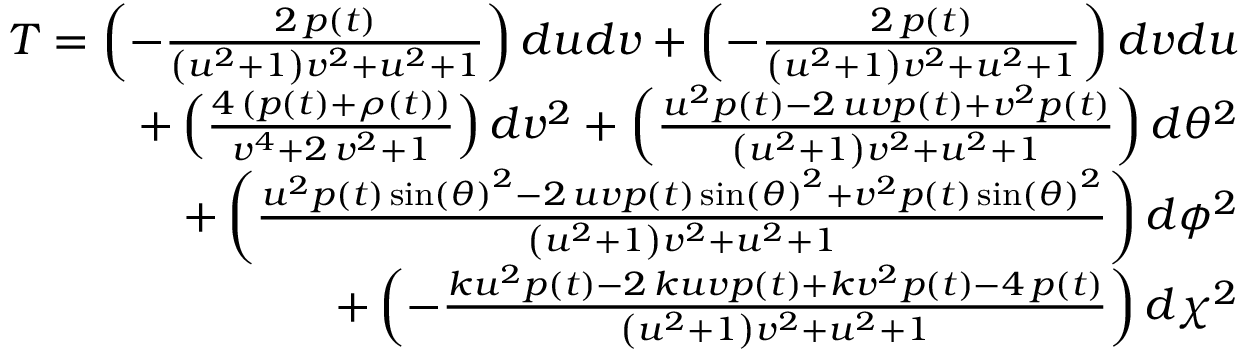Convert formula to latex. <formula><loc_0><loc_0><loc_500><loc_500>\begin{array} { r } { T = \left ( - \frac { 2 \, p \left ( t \right ) } { { \left ( u ^ { 2 } + 1 \right ) } v ^ { 2 } + u ^ { 2 } + 1 } \right ) d u d v + \left ( - \frac { 2 \, p \left ( t \right ) } { { \left ( u ^ { 2 } + 1 \right ) } v ^ { 2 } + u ^ { 2 } + 1 } \right ) d v d u } \\ { + \left ( \frac { 4 \, { \left ( p \left ( t \right ) + \rho \left ( t \right ) \right ) } } { v ^ { 4 } + 2 \, v ^ { 2 } + 1 } \right ) d v ^ { 2 } + \left ( \frac { u ^ { 2 } p \left ( t \right ) - 2 \, u v p \left ( t \right ) + v ^ { 2 } p \left ( t \right ) } { { \left ( u ^ { 2 } + 1 \right ) } v ^ { 2 } + u ^ { 2 } + 1 } \right ) d \theta ^ { 2 } } \\ { + \left ( \frac { u ^ { 2 } p \left ( t \right ) \sin \left ( { \theta } \right ) ^ { 2 } - 2 \, u v p \left ( t \right ) \sin \left ( { \theta } \right ) ^ { 2 } + v ^ { 2 } p \left ( t \right ) \sin \left ( { \theta } \right ) ^ { 2 } } { { \left ( u ^ { 2 } + 1 \right ) } v ^ { 2 } + u ^ { 2 } + 1 } \right ) d \phi ^ { 2 } } \\ { + \left ( - \frac { k u ^ { 2 } p \left ( t \right ) - 2 \, k u v p \left ( t \right ) + k v ^ { 2 } p \left ( t \right ) - 4 \, p \left ( t \right ) } { { \left ( u ^ { 2 } + 1 \right ) } v ^ { 2 } + u ^ { 2 } + 1 } \right ) d \chi ^ { 2 } } \end{array}</formula> 